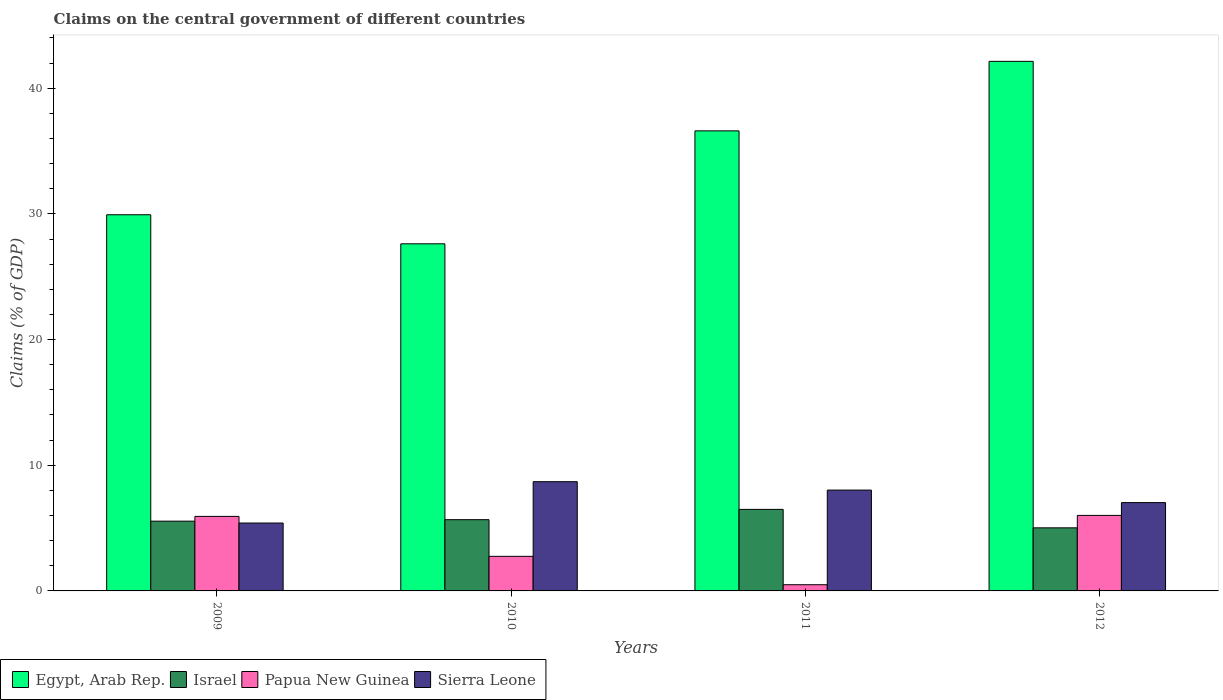How many different coloured bars are there?
Keep it short and to the point. 4. Are the number of bars on each tick of the X-axis equal?
Provide a short and direct response. Yes. How many bars are there on the 1st tick from the left?
Your answer should be very brief. 4. What is the label of the 2nd group of bars from the left?
Your answer should be compact. 2010. What is the percentage of GDP claimed on the central government in Sierra Leone in 2009?
Keep it short and to the point. 5.4. Across all years, what is the maximum percentage of GDP claimed on the central government in Egypt, Arab Rep.?
Provide a short and direct response. 42.14. Across all years, what is the minimum percentage of GDP claimed on the central government in Egypt, Arab Rep.?
Give a very brief answer. 27.62. What is the total percentage of GDP claimed on the central government in Israel in the graph?
Keep it short and to the point. 22.73. What is the difference between the percentage of GDP claimed on the central government in Egypt, Arab Rep. in 2010 and that in 2011?
Provide a short and direct response. -8.99. What is the difference between the percentage of GDP claimed on the central government in Israel in 2009 and the percentage of GDP claimed on the central government in Papua New Guinea in 2012?
Your answer should be very brief. -0.46. What is the average percentage of GDP claimed on the central government in Israel per year?
Keep it short and to the point. 5.68. In the year 2009, what is the difference between the percentage of GDP claimed on the central government in Egypt, Arab Rep. and percentage of GDP claimed on the central government in Israel?
Your response must be concise. 24.38. In how many years, is the percentage of GDP claimed on the central government in Egypt, Arab Rep. greater than 28 %?
Keep it short and to the point. 3. What is the ratio of the percentage of GDP claimed on the central government in Sierra Leone in 2011 to that in 2012?
Offer a terse response. 1.14. Is the percentage of GDP claimed on the central government in Israel in 2010 less than that in 2012?
Ensure brevity in your answer.  No. Is the difference between the percentage of GDP claimed on the central government in Egypt, Arab Rep. in 2011 and 2012 greater than the difference between the percentage of GDP claimed on the central government in Israel in 2011 and 2012?
Offer a terse response. No. What is the difference between the highest and the second highest percentage of GDP claimed on the central government in Papua New Guinea?
Make the answer very short. 0.08. What is the difference between the highest and the lowest percentage of GDP claimed on the central government in Sierra Leone?
Make the answer very short. 3.29. In how many years, is the percentage of GDP claimed on the central government in Papua New Guinea greater than the average percentage of GDP claimed on the central government in Papua New Guinea taken over all years?
Ensure brevity in your answer.  2. What does the 3rd bar from the left in 2010 represents?
Ensure brevity in your answer.  Papua New Guinea. What does the 4th bar from the right in 2009 represents?
Your response must be concise. Egypt, Arab Rep. What is the difference between two consecutive major ticks on the Y-axis?
Ensure brevity in your answer.  10. Does the graph contain grids?
Ensure brevity in your answer.  No. How many legend labels are there?
Your answer should be compact. 4. How are the legend labels stacked?
Ensure brevity in your answer.  Horizontal. What is the title of the graph?
Your answer should be compact. Claims on the central government of different countries. Does "Mauritania" appear as one of the legend labels in the graph?
Give a very brief answer. No. What is the label or title of the Y-axis?
Your response must be concise. Claims (% of GDP). What is the Claims (% of GDP) in Egypt, Arab Rep. in 2009?
Offer a terse response. 29.93. What is the Claims (% of GDP) in Israel in 2009?
Give a very brief answer. 5.55. What is the Claims (% of GDP) of Papua New Guinea in 2009?
Provide a succinct answer. 5.93. What is the Claims (% of GDP) in Sierra Leone in 2009?
Offer a terse response. 5.4. What is the Claims (% of GDP) in Egypt, Arab Rep. in 2010?
Your response must be concise. 27.62. What is the Claims (% of GDP) in Israel in 2010?
Provide a succinct answer. 5.67. What is the Claims (% of GDP) in Papua New Guinea in 2010?
Provide a succinct answer. 2.75. What is the Claims (% of GDP) in Sierra Leone in 2010?
Your answer should be very brief. 8.69. What is the Claims (% of GDP) of Egypt, Arab Rep. in 2011?
Ensure brevity in your answer.  36.6. What is the Claims (% of GDP) in Israel in 2011?
Give a very brief answer. 6.49. What is the Claims (% of GDP) of Papua New Guinea in 2011?
Give a very brief answer. 0.49. What is the Claims (% of GDP) in Sierra Leone in 2011?
Ensure brevity in your answer.  8.02. What is the Claims (% of GDP) of Egypt, Arab Rep. in 2012?
Ensure brevity in your answer.  42.14. What is the Claims (% of GDP) in Israel in 2012?
Make the answer very short. 5.02. What is the Claims (% of GDP) in Papua New Guinea in 2012?
Keep it short and to the point. 6.01. What is the Claims (% of GDP) of Sierra Leone in 2012?
Your response must be concise. 7.03. Across all years, what is the maximum Claims (% of GDP) in Egypt, Arab Rep.?
Give a very brief answer. 42.14. Across all years, what is the maximum Claims (% of GDP) of Israel?
Your response must be concise. 6.49. Across all years, what is the maximum Claims (% of GDP) of Papua New Guinea?
Make the answer very short. 6.01. Across all years, what is the maximum Claims (% of GDP) in Sierra Leone?
Your answer should be very brief. 8.69. Across all years, what is the minimum Claims (% of GDP) in Egypt, Arab Rep.?
Ensure brevity in your answer.  27.62. Across all years, what is the minimum Claims (% of GDP) in Israel?
Offer a terse response. 5.02. Across all years, what is the minimum Claims (% of GDP) in Papua New Guinea?
Your answer should be compact. 0.49. Across all years, what is the minimum Claims (% of GDP) of Sierra Leone?
Your answer should be very brief. 5.4. What is the total Claims (% of GDP) of Egypt, Arab Rep. in the graph?
Your response must be concise. 136.29. What is the total Claims (% of GDP) in Israel in the graph?
Your response must be concise. 22.73. What is the total Claims (% of GDP) in Papua New Guinea in the graph?
Provide a succinct answer. 15.18. What is the total Claims (% of GDP) in Sierra Leone in the graph?
Your response must be concise. 29.14. What is the difference between the Claims (% of GDP) of Egypt, Arab Rep. in 2009 and that in 2010?
Your answer should be compact. 2.31. What is the difference between the Claims (% of GDP) of Israel in 2009 and that in 2010?
Keep it short and to the point. -0.12. What is the difference between the Claims (% of GDP) in Papua New Guinea in 2009 and that in 2010?
Offer a terse response. 3.18. What is the difference between the Claims (% of GDP) in Sierra Leone in 2009 and that in 2010?
Offer a very short reply. -3.29. What is the difference between the Claims (% of GDP) in Egypt, Arab Rep. in 2009 and that in 2011?
Your response must be concise. -6.67. What is the difference between the Claims (% of GDP) of Israel in 2009 and that in 2011?
Offer a very short reply. -0.94. What is the difference between the Claims (% of GDP) of Papua New Guinea in 2009 and that in 2011?
Provide a short and direct response. 5.44. What is the difference between the Claims (% of GDP) in Sierra Leone in 2009 and that in 2011?
Provide a succinct answer. -2.62. What is the difference between the Claims (% of GDP) in Egypt, Arab Rep. in 2009 and that in 2012?
Keep it short and to the point. -12.21. What is the difference between the Claims (% of GDP) in Israel in 2009 and that in 2012?
Your response must be concise. 0.53. What is the difference between the Claims (% of GDP) in Papua New Guinea in 2009 and that in 2012?
Provide a succinct answer. -0.08. What is the difference between the Claims (% of GDP) in Sierra Leone in 2009 and that in 2012?
Offer a very short reply. -1.62. What is the difference between the Claims (% of GDP) in Egypt, Arab Rep. in 2010 and that in 2011?
Your answer should be very brief. -8.99. What is the difference between the Claims (% of GDP) in Israel in 2010 and that in 2011?
Ensure brevity in your answer.  -0.82. What is the difference between the Claims (% of GDP) in Papua New Guinea in 2010 and that in 2011?
Make the answer very short. 2.26. What is the difference between the Claims (% of GDP) of Sierra Leone in 2010 and that in 2011?
Give a very brief answer. 0.67. What is the difference between the Claims (% of GDP) in Egypt, Arab Rep. in 2010 and that in 2012?
Keep it short and to the point. -14.52. What is the difference between the Claims (% of GDP) in Israel in 2010 and that in 2012?
Offer a very short reply. 0.65. What is the difference between the Claims (% of GDP) in Papua New Guinea in 2010 and that in 2012?
Ensure brevity in your answer.  -3.26. What is the difference between the Claims (% of GDP) of Sierra Leone in 2010 and that in 2012?
Offer a terse response. 1.66. What is the difference between the Claims (% of GDP) of Egypt, Arab Rep. in 2011 and that in 2012?
Provide a succinct answer. -5.53. What is the difference between the Claims (% of GDP) of Israel in 2011 and that in 2012?
Give a very brief answer. 1.47. What is the difference between the Claims (% of GDP) of Papua New Guinea in 2011 and that in 2012?
Your answer should be compact. -5.52. What is the difference between the Claims (% of GDP) of Sierra Leone in 2011 and that in 2012?
Ensure brevity in your answer.  1. What is the difference between the Claims (% of GDP) of Egypt, Arab Rep. in 2009 and the Claims (% of GDP) of Israel in 2010?
Your answer should be compact. 24.26. What is the difference between the Claims (% of GDP) of Egypt, Arab Rep. in 2009 and the Claims (% of GDP) of Papua New Guinea in 2010?
Keep it short and to the point. 27.18. What is the difference between the Claims (% of GDP) in Egypt, Arab Rep. in 2009 and the Claims (% of GDP) in Sierra Leone in 2010?
Your response must be concise. 21.24. What is the difference between the Claims (% of GDP) in Israel in 2009 and the Claims (% of GDP) in Papua New Guinea in 2010?
Provide a succinct answer. 2.8. What is the difference between the Claims (% of GDP) of Israel in 2009 and the Claims (% of GDP) of Sierra Leone in 2010?
Make the answer very short. -3.14. What is the difference between the Claims (% of GDP) of Papua New Guinea in 2009 and the Claims (% of GDP) of Sierra Leone in 2010?
Make the answer very short. -2.76. What is the difference between the Claims (% of GDP) in Egypt, Arab Rep. in 2009 and the Claims (% of GDP) in Israel in 2011?
Provide a succinct answer. 23.44. What is the difference between the Claims (% of GDP) in Egypt, Arab Rep. in 2009 and the Claims (% of GDP) in Papua New Guinea in 2011?
Keep it short and to the point. 29.44. What is the difference between the Claims (% of GDP) of Egypt, Arab Rep. in 2009 and the Claims (% of GDP) of Sierra Leone in 2011?
Offer a very short reply. 21.91. What is the difference between the Claims (% of GDP) of Israel in 2009 and the Claims (% of GDP) of Papua New Guinea in 2011?
Offer a very short reply. 5.06. What is the difference between the Claims (% of GDP) in Israel in 2009 and the Claims (% of GDP) in Sierra Leone in 2011?
Your answer should be very brief. -2.47. What is the difference between the Claims (% of GDP) of Papua New Guinea in 2009 and the Claims (% of GDP) of Sierra Leone in 2011?
Your response must be concise. -2.09. What is the difference between the Claims (% of GDP) in Egypt, Arab Rep. in 2009 and the Claims (% of GDP) in Israel in 2012?
Your answer should be very brief. 24.91. What is the difference between the Claims (% of GDP) of Egypt, Arab Rep. in 2009 and the Claims (% of GDP) of Papua New Guinea in 2012?
Provide a short and direct response. 23.92. What is the difference between the Claims (% of GDP) of Egypt, Arab Rep. in 2009 and the Claims (% of GDP) of Sierra Leone in 2012?
Give a very brief answer. 22.9. What is the difference between the Claims (% of GDP) in Israel in 2009 and the Claims (% of GDP) in Papua New Guinea in 2012?
Provide a short and direct response. -0.46. What is the difference between the Claims (% of GDP) in Israel in 2009 and the Claims (% of GDP) in Sierra Leone in 2012?
Provide a succinct answer. -1.48. What is the difference between the Claims (% of GDP) of Papua New Guinea in 2009 and the Claims (% of GDP) of Sierra Leone in 2012?
Your response must be concise. -1.1. What is the difference between the Claims (% of GDP) of Egypt, Arab Rep. in 2010 and the Claims (% of GDP) of Israel in 2011?
Your answer should be compact. 21.13. What is the difference between the Claims (% of GDP) in Egypt, Arab Rep. in 2010 and the Claims (% of GDP) in Papua New Guinea in 2011?
Keep it short and to the point. 27.13. What is the difference between the Claims (% of GDP) in Egypt, Arab Rep. in 2010 and the Claims (% of GDP) in Sierra Leone in 2011?
Make the answer very short. 19.6. What is the difference between the Claims (% of GDP) in Israel in 2010 and the Claims (% of GDP) in Papua New Guinea in 2011?
Make the answer very short. 5.18. What is the difference between the Claims (% of GDP) of Israel in 2010 and the Claims (% of GDP) of Sierra Leone in 2011?
Your answer should be very brief. -2.35. What is the difference between the Claims (% of GDP) of Papua New Guinea in 2010 and the Claims (% of GDP) of Sierra Leone in 2011?
Provide a succinct answer. -5.27. What is the difference between the Claims (% of GDP) in Egypt, Arab Rep. in 2010 and the Claims (% of GDP) in Israel in 2012?
Give a very brief answer. 22.6. What is the difference between the Claims (% of GDP) of Egypt, Arab Rep. in 2010 and the Claims (% of GDP) of Papua New Guinea in 2012?
Make the answer very short. 21.61. What is the difference between the Claims (% of GDP) of Egypt, Arab Rep. in 2010 and the Claims (% of GDP) of Sierra Leone in 2012?
Ensure brevity in your answer.  20.59. What is the difference between the Claims (% of GDP) in Israel in 2010 and the Claims (% of GDP) in Papua New Guinea in 2012?
Your answer should be compact. -0.34. What is the difference between the Claims (% of GDP) in Israel in 2010 and the Claims (% of GDP) in Sierra Leone in 2012?
Offer a terse response. -1.36. What is the difference between the Claims (% of GDP) in Papua New Guinea in 2010 and the Claims (% of GDP) in Sierra Leone in 2012?
Provide a succinct answer. -4.28. What is the difference between the Claims (% of GDP) in Egypt, Arab Rep. in 2011 and the Claims (% of GDP) in Israel in 2012?
Your answer should be compact. 31.59. What is the difference between the Claims (% of GDP) in Egypt, Arab Rep. in 2011 and the Claims (% of GDP) in Papua New Guinea in 2012?
Ensure brevity in your answer.  30.6. What is the difference between the Claims (% of GDP) of Egypt, Arab Rep. in 2011 and the Claims (% of GDP) of Sierra Leone in 2012?
Keep it short and to the point. 29.58. What is the difference between the Claims (% of GDP) of Israel in 2011 and the Claims (% of GDP) of Papua New Guinea in 2012?
Your answer should be compact. 0.48. What is the difference between the Claims (% of GDP) of Israel in 2011 and the Claims (% of GDP) of Sierra Leone in 2012?
Your answer should be very brief. -0.54. What is the difference between the Claims (% of GDP) of Papua New Guinea in 2011 and the Claims (% of GDP) of Sierra Leone in 2012?
Your answer should be very brief. -6.54. What is the average Claims (% of GDP) of Egypt, Arab Rep. per year?
Ensure brevity in your answer.  34.07. What is the average Claims (% of GDP) of Israel per year?
Offer a terse response. 5.68. What is the average Claims (% of GDP) of Papua New Guinea per year?
Keep it short and to the point. 3.8. What is the average Claims (% of GDP) in Sierra Leone per year?
Your answer should be very brief. 7.29. In the year 2009, what is the difference between the Claims (% of GDP) in Egypt, Arab Rep. and Claims (% of GDP) in Israel?
Give a very brief answer. 24.38. In the year 2009, what is the difference between the Claims (% of GDP) in Egypt, Arab Rep. and Claims (% of GDP) in Papua New Guinea?
Provide a succinct answer. 24. In the year 2009, what is the difference between the Claims (% of GDP) of Egypt, Arab Rep. and Claims (% of GDP) of Sierra Leone?
Your response must be concise. 24.53. In the year 2009, what is the difference between the Claims (% of GDP) of Israel and Claims (% of GDP) of Papua New Guinea?
Provide a short and direct response. -0.38. In the year 2009, what is the difference between the Claims (% of GDP) in Israel and Claims (% of GDP) in Sierra Leone?
Keep it short and to the point. 0.15. In the year 2009, what is the difference between the Claims (% of GDP) in Papua New Guinea and Claims (% of GDP) in Sierra Leone?
Offer a terse response. 0.53. In the year 2010, what is the difference between the Claims (% of GDP) of Egypt, Arab Rep. and Claims (% of GDP) of Israel?
Keep it short and to the point. 21.95. In the year 2010, what is the difference between the Claims (% of GDP) in Egypt, Arab Rep. and Claims (% of GDP) in Papua New Guinea?
Ensure brevity in your answer.  24.87. In the year 2010, what is the difference between the Claims (% of GDP) of Egypt, Arab Rep. and Claims (% of GDP) of Sierra Leone?
Your answer should be compact. 18.93. In the year 2010, what is the difference between the Claims (% of GDP) in Israel and Claims (% of GDP) in Papua New Guinea?
Your answer should be compact. 2.92. In the year 2010, what is the difference between the Claims (% of GDP) in Israel and Claims (% of GDP) in Sierra Leone?
Ensure brevity in your answer.  -3.02. In the year 2010, what is the difference between the Claims (% of GDP) in Papua New Guinea and Claims (% of GDP) in Sierra Leone?
Make the answer very short. -5.94. In the year 2011, what is the difference between the Claims (% of GDP) of Egypt, Arab Rep. and Claims (% of GDP) of Israel?
Provide a short and direct response. 30.12. In the year 2011, what is the difference between the Claims (% of GDP) of Egypt, Arab Rep. and Claims (% of GDP) of Papua New Guinea?
Keep it short and to the point. 36.11. In the year 2011, what is the difference between the Claims (% of GDP) of Egypt, Arab Rep. and Claims (% of GDP) of Sierra Leone?
Make the answer very short. 28.58. In the year 2011, what is the difference between the Claims (% of GDP) in Israel and Claims (% of GDP) in Papua New Guinea?
Your answer should be compact. 5.99. In the year 2011, what is the difference between the Claims (% of GDP) in Israel and Claims (% of GDP) in Sierra Leone?
Your answer should be compact. -1.54. In the year 2011, what is the difference between the Claims (% of GDP) in Papua New Guinea and Claims (% of GDP) in Sierra Leone?
Make the answer very short. -7.53. In the year 2012, what is the difference between the Claims (% of GDP) of Egypt, Arab Rep. and Claims (% of GDP) of Israel?
Keep it short and to the point. 37.12. In the year 2012, what is the difference between the Claims (% of GDP) of Egypt, Arab Rep. and Claims (% of GDP) of Papua New Guinea?
Your answer should be compact. 36.13. In the year 2012, what is the difference between the Claims (% of GDP) in Egypt, Arab Rep. and Claims (% of GDP) in Sierra Leone?
Keep it short and to the point. 35.11. In the year 2012, what is the difference between the Claims (% of GDP) in Israel and Claims (% of GDP) in Papua New Guinea?
Provide a short and direct response. -0.99. In the year 2012, what is the difference between the Claims (% of GDP) of Israel and Claims (% of GDP) of Sierra Leone?
Provide a succinct answer. -2.01. In the year 2012, what is the difference between the Claims (% of GDP) in Papua New Guinea and Claims (% of GDP) in Sierra Leone?
Offer a very short reply. -1.02. What is the ratio of the Claims (% of GDP) of Egypt, Arab Rep. in 2009 to that in 2010?
Ensure brevity in your answer.  1.08. What is the ratio of the Claims (% of GDP) of Israel in 2009 to that in 2010?
Your response must be concise. 0.98. What is the ratio of the Claims (% of GDP) in Papua New Guinea in 2009 to that in 2010?
Keep it short and to the point. 2.15. What is the ratio of the Claims (% of GDP) of Sierra Leone in 2009 to that in 2010?
Give a very brief answer. 0.62. What is the ratio of the Claims (% of GDP) of Egypt, Arab Rep. in 2009 to that in 2011?
Offer a very short reply. 0.82. What is the ratio of the Claims (% of GDP) of Israel in 2009 to that in 2011?
Ensure brevity in your answer.  0.86. What is the ratio of the Claims (% of GDP) in Papua New Guinea in 2009 to that in 2011?
Provide a succinct answer. 12.04. What is the ratio of the Claims (% of GDP) of Sierra Leone in 2009 to that in 2011?
Your answer should be compact. 0.67. What is the ratio of the Claims (% of GDP) of Egypt, Arab Rep. in 2009 to that in 2012?
Your answer should be very brief. 0.71. What is the ratio of the Claims (% of GDP) in Israel in 2009 to that in 2012?
Ensure brevity in your answer.  1.11. What is the ratio of the Claims (% of GDP) of Sierra Leone in 2009 to that in 2012?
Your answer should be very brief. 0.77. What is the ratio of the Claims (% of GDP) in Egypt, Arab Rep. in 2010 to that in 2011?
Your response must be concise. 0.75. What is the ratio of the Claims (% of GDP) in Israel in 2010 to that in 2011?
Provide a succinct answer. 0.87. What is the ratio of the Claims (% of GDP) in Papua New Guinea in 2010 to that in 2011?
Ensure brevity in your answer.  5.59. What is the ratio of the Claims (% of GDP) of Sierra Leone in 2010 to that in 2011?
Ensure brevity in your answer.  1.08. What is the ratio of the Claims (% of GDP) of Egypt, Arab Rep. in 2010 to that in 2012?
Make the answer very short. 0.66. What is the ratio of the Claims (% of GDP) in Israel in 2010 to that in 2012?
Offer a terse response. 1.13. What is the ratio of the Claims (% of GDP) of Papua New Guinea in 2010 to that in 2012?
Make the answer very short. 0.46. What is the ratio of the Claims (% of GDP) in Sierra Leone in 2010 to that in 2012?
Your answer should be compact. 1.24. What is the ratio of the Claims (% of GDP) of Egypt, Arab Rep. in 2011 to that in 2012?
Provide a short and direct response. 0.87. What is the ratio of the Claims (% of GDP) in Israel in 2011 to that in 2012?
Provide a short and direct response. 1.29. What is the ratio of the Claims (% of GDP) in Papua New Guinea in 2011 to that in 2012?
Your answer should be compact. 0.08. What is the ratio of the Claims (% of GDP) of Sierra Leone in 2011 to that in 2012?
Your answer should be compact. 1.14. What is the difference between the highest and the second highest Claims (% of GDP) of Egypt, Arab Rep.?
Your answer should be compact. 5.53. What is the difference between the highest and the second highest Claims (% of GDP) of Israel?
Keep it short and to the point. 0.82. What is the difference between the highest and the second highest Claims (% of GDP) in Papua New Guinea?
Offer a terse response. 0.08. What is the difference between the highest and the second highest Claims (% of GDP) of Sierra Leone?
Make the answer very short. 0.67. What is the difference between the highest and the lowest Claims (% of GDP) in Egypt, Arab Rep.?
Keep it short and to the point. 14.52. What is the difference between the highest and the lowest Claims (% of GDP) in Israel?
Offer a very short reply. 1.47. What is the difference between the highest and the lowest Claims (% of GDP) in Papua New Guinea?
Keep it short and to the point. 5.52. What is the difference between the highest and the lowest Claims (% of GDP) in Sierra Leone?
Give a very brief answer. 3.29. 